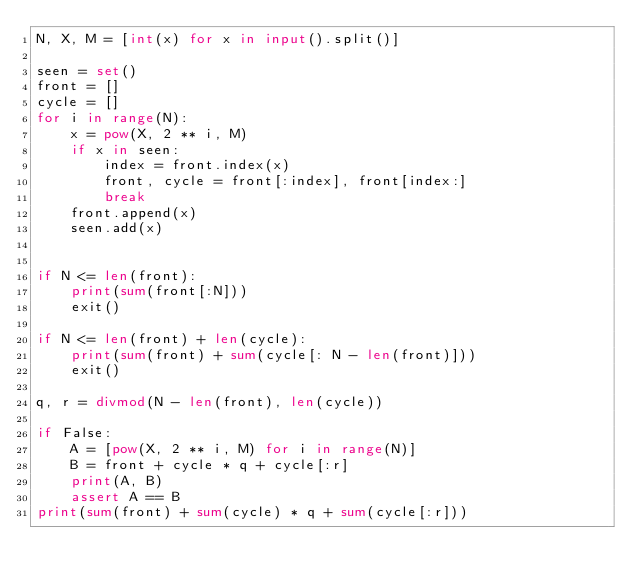<code> <loc_0><loc_0><loc_500><loc_500><_Python_>N, X, M = [int(x) for x in input().split()]

seen = set()
front = []
cycle = []
for i in range(N):
    x = pow(X, 2 ** i, M)
    if x in seen:
        index = front.index(x)
        front, cycle = front[:index], front[index:]
        break
    front.append(x)
    seen.add(x)


if N <= len(front):
    print(sum(front[:N]))
    exit()

if N <= len(front) + len(cycle):
    print(sum(front) + sum(cycle[: N - len(front)]))
    exit()

q, r = divmod(N - len(front), len(cycle))

if False:
    A = [pow(X, 2 ** i, M) for i in range(N)]
    B = front + cycle * q + cycle[:r]
    print(A, B)
    assert A == B
print(sum(front) + sum(cycle) * q + sum(cycle[:r]))
</code> 